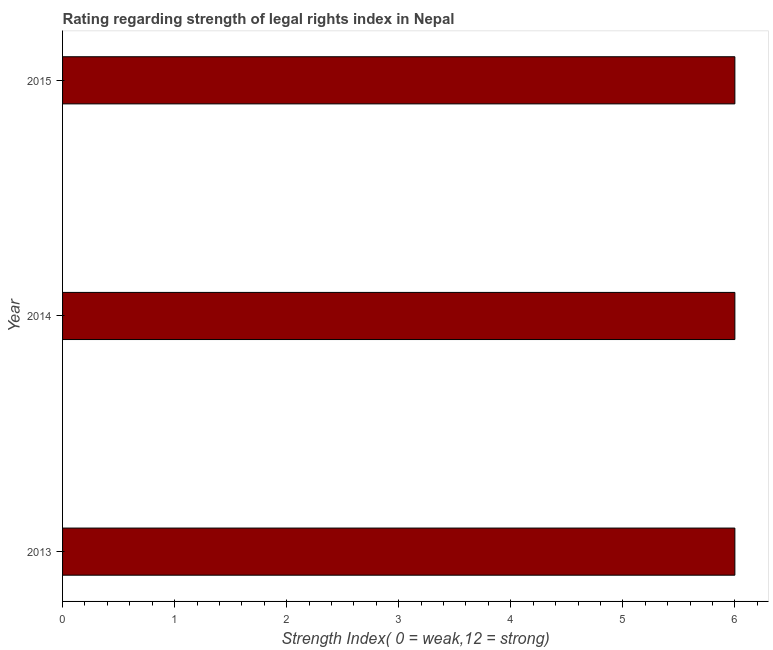Does the graph contain any zero values?
Provide a short and direct response. No. Does the graph contain grids?
Provide a succinct answer. No. What is the title of the graph?
Your answer should be very brief. Rating regarding strength of legal rights index in Nepal. What is the label or title of the X-axis?
Give a very brief answer. Strength Index( 0 = weak,12 = strong). What is the strength of legal rights index in 2015?
Your response must be concise. 6. Across all years, what is the minimum strength of legal rights index?
Give a very brief answer. 6. What is the difference between the strength of legal rights index in 2013 and 2015?
Make the answer very short. 0. In how many years, is the strength of legal rights index greater than 1 ?
Provide a short and direct response. 3. What is the ratio of the strength of legal rights index in 2014 to that in 2015?
Make the answer very short. 1. Is the strength of legal rights index in 2013 less than that in 2015?
Ensure brevity in your answer.  No. Is the difference between the strength of legal rights index in 2013 and 2015 greater than the difference between any two years?
Ensure brevity in your answer.  Yes. What is the difference between the highest and the second highest strength of legal rights index?
Your response must be concise. 0. Is the sum of the strength of legal rights index in 2013 and 2015 greater than the maximum strength of legal rights index across all years?
Provide a succinct answer. Yes. How many bars are there?
Keep it short and to the point. 3. Are all the bars in the graph horizontal?
Provide a short and direct response. Yes. What is the Strength Index( 0 = weak,12 = strong) of 2013?
Give a very brief answer. 6. What is the Strength Index( 0 = weak,12 = strong) in 2014?
Offer a terse response. 6. What is the Strength Index( 0 = weak,12 = strong) of 2015?
Offer a terse response. 6. What is the difference between the Strength Index( 0 = weak,12 = strong) in 2013 and 2015?
Your answer should be very brief. 0. What is the ratio of the Strength Index( 0 = weak,12 = strong) in 2013 to that in 2014?
Your answer should be compact. 1. What is the ratio of the Strength Index( 0 = weak,12 = strong) in 2014 to that in 2015?
Ensure brevity in your answer.  1. 